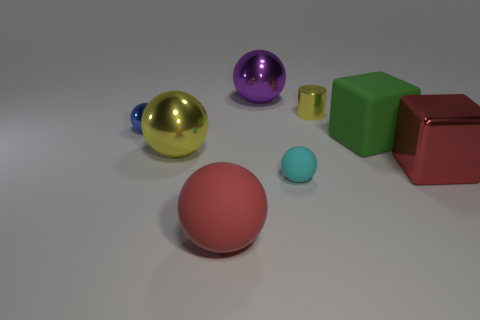Subtract 2 balls. How many balls are left? 3 Subtract all brown balls. Subtract all cyan cubes. How many balls are left? 5 Add 2 green things. How many objects exist? 10 Subtract all balls. How many objects are left? 3 Subtract all small red spheres. Subtract all large green matte objects. How many objects are left? 7 Add 4 large red metal cubes. How many large red metal cubes are left? 5 Add 2 shiny things. How many shiny things exist? 7 Subtract 1 blue spheres. How many objects are left? 7 